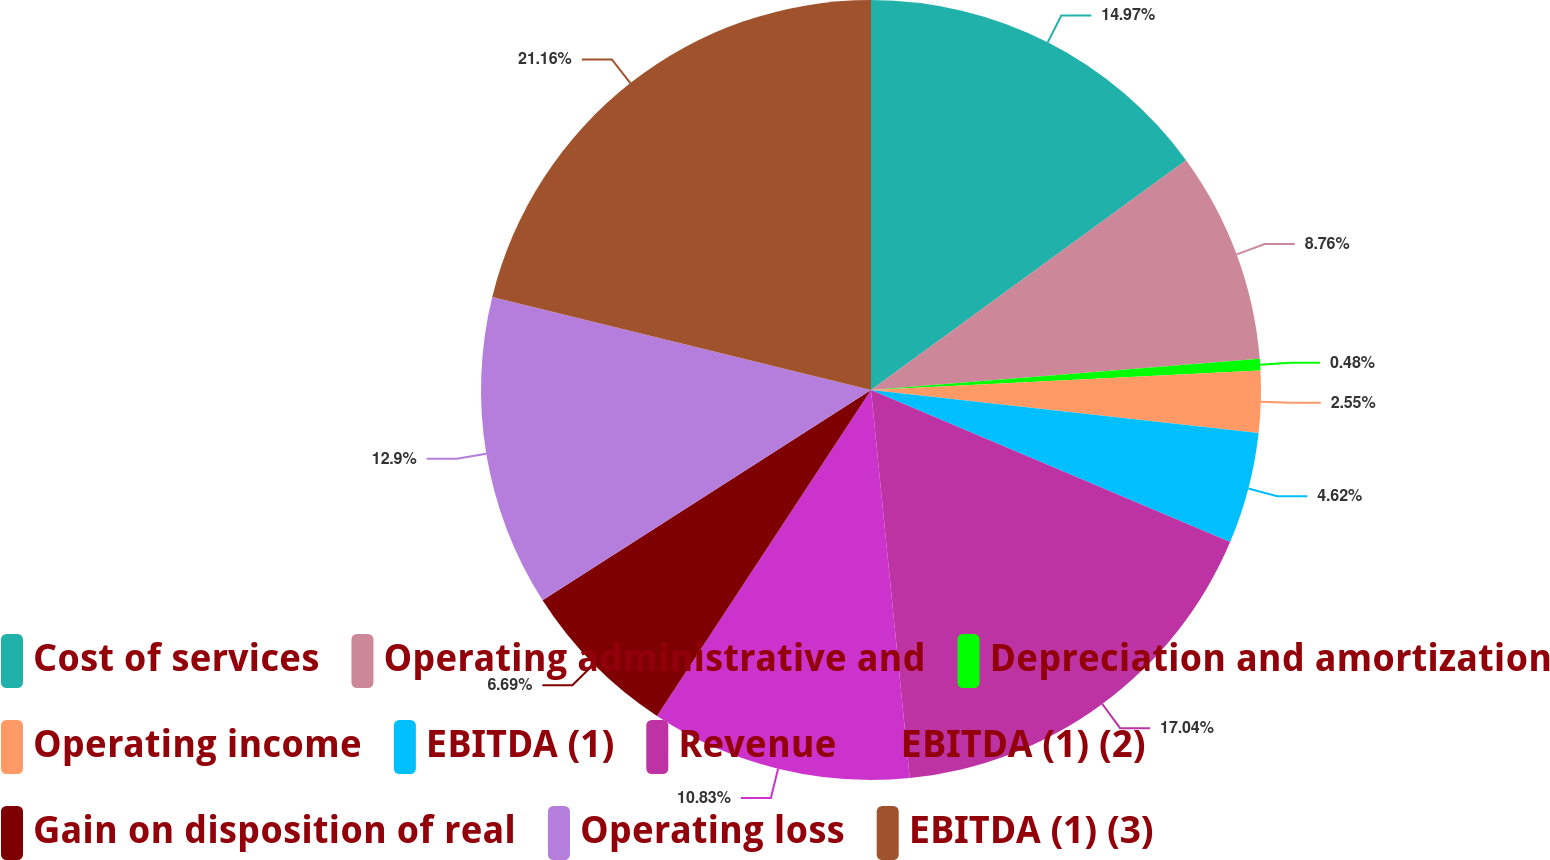<chart> <loc_0><loc_0><loc_500><loc_500><pie_chart><fcel>Cost of services<fcel>Operating administrative and<fcel>Depreciation and amortization<fcel>Operating income<fcel>EBITDA (1)<fcel>Revenue<fcel>EBITDA (1) (2)<fcel>Gain on disposition of real<fcel>Operating loss<fcel>EBITDA (1) (3)<nl><fcel>14.97%<fcel>8.76%<fcel>0.48%<fcel>2.55%<fcel>4.62%<fcel>17.04%<fcel>10.83%<fcel>6.69%<fcel>12.9%<fcel>21.17%<nl></chart> 